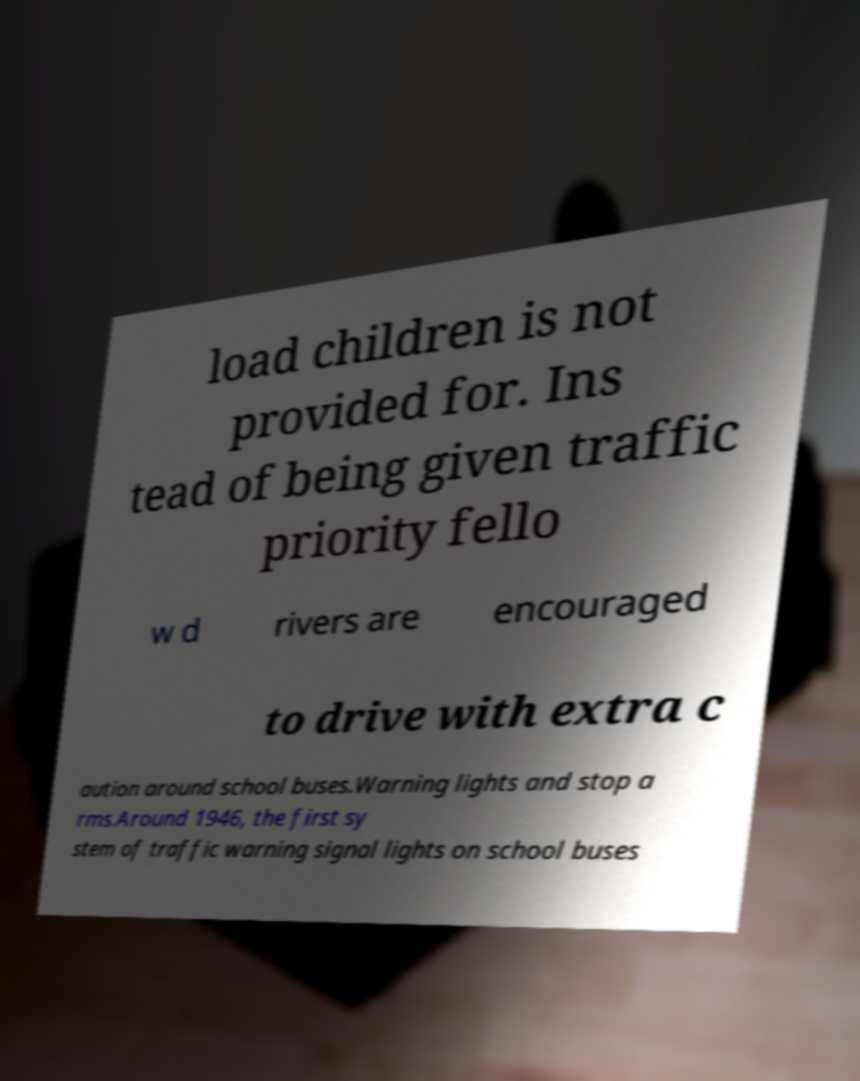There's text embedded in this image that I need extracted. Can you transcribe it verbatim? load children is not provided for. Ins tead of being given traffic priority fello w d rivers are encouraged to drive with extra c aution around school buses.Warning lights and stop a rms.Around 1946, the first sy stem of traffic warning signal lights on school buses 